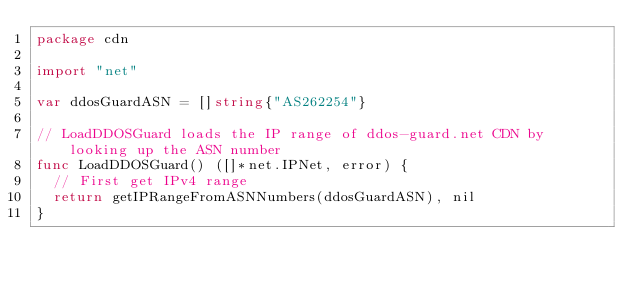Convert code to text. <code><loc_0><loc_0><loc_500><loc_500><_Go_>package cdn

import "net"

var ddosGuardASN = []string{"AS262254"}

// LoadDDOSGuard loads the IP range of ddos-guard.net CDN by looking up the ASN number
func LoadDDOSGuard() ([]*net.IPNet, error) {
	// First get IPv4 range
	return getIPRangeFromASNNumbers(ddosGuardASN), nil
}
</code> 